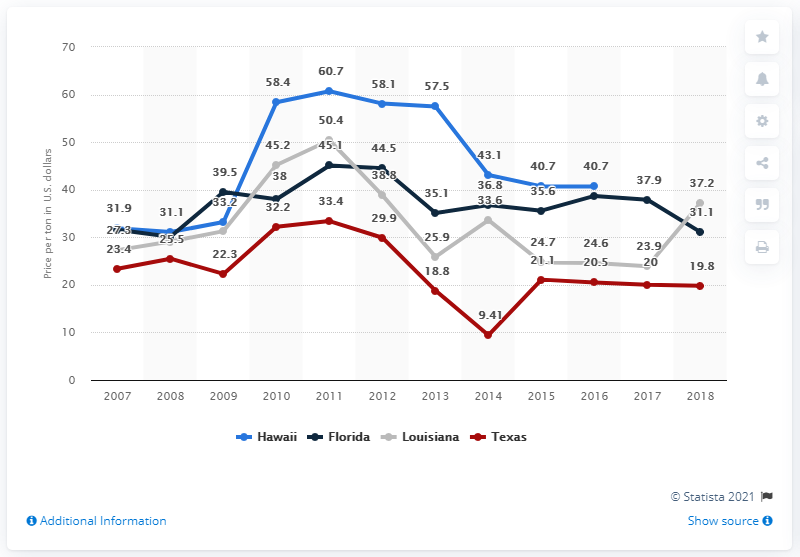Outline some significant characteristics in this image. In 2014, the value of one ton of sugar cane was approximately 43.1 dollars in the United States. The lower number of the red line was 9.41. Hawaii had the largest one-year increase in state population, according to data. 